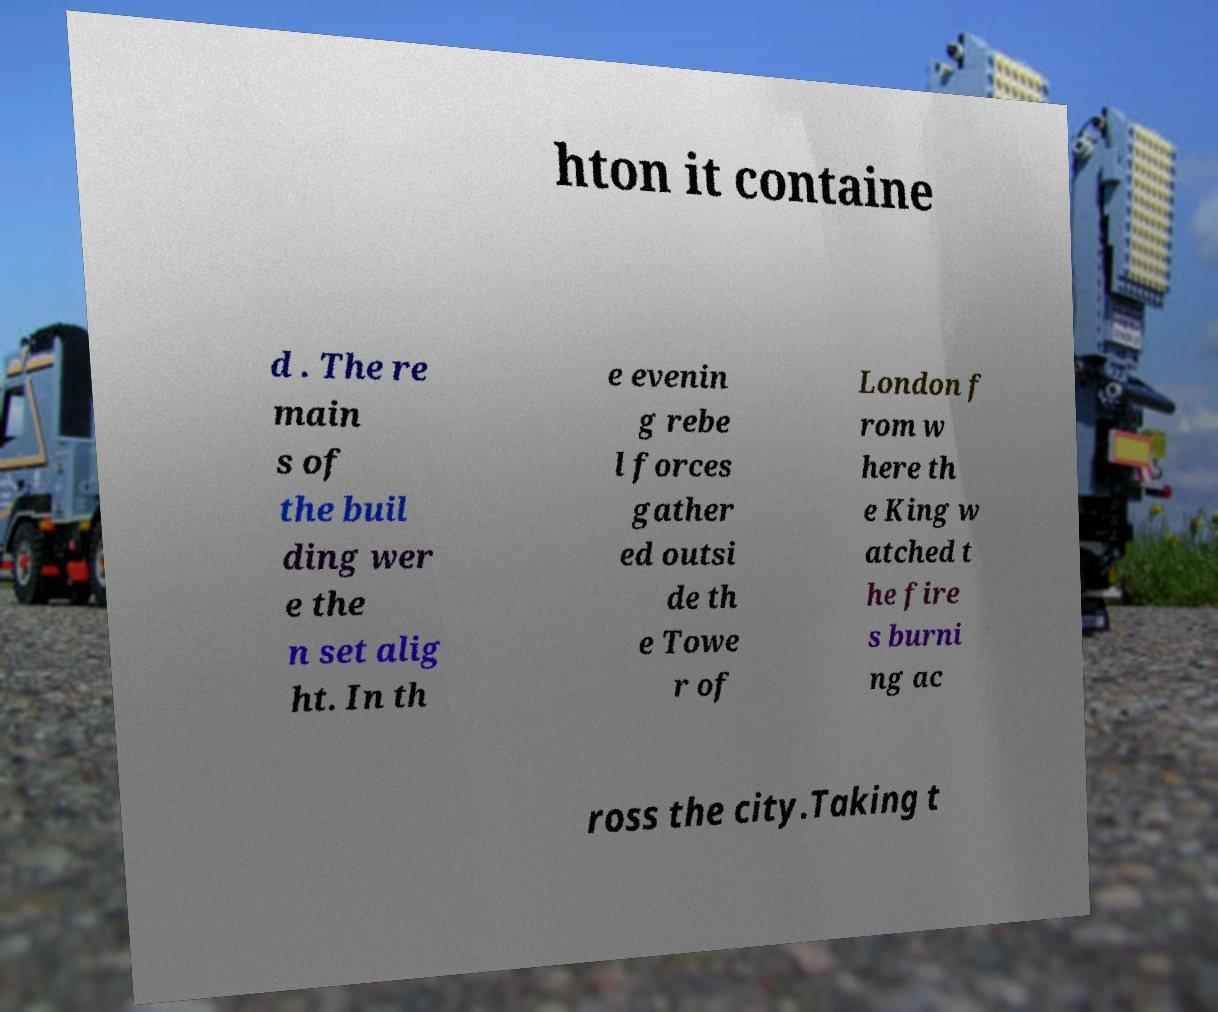There's text embedded in this image that I need extracted. Can you transcribe it verbatim? hton it containe d . The re main s of the buil ding wer e the n set alig ht. In th e evenin g rebe l forces gather ed outsi de th e Towe r of London f rom w here th e King w atched t he fire s burni ng ac ross the city.Taking t 